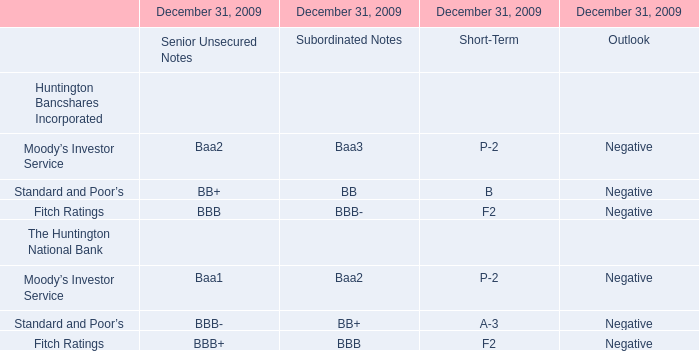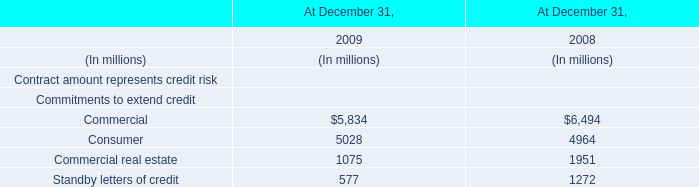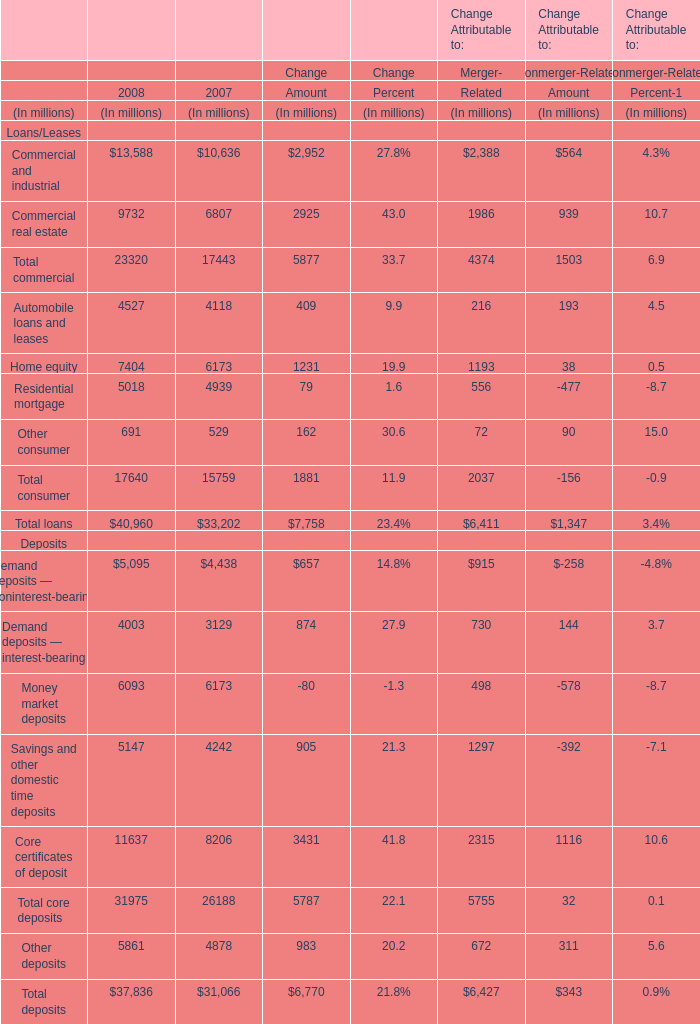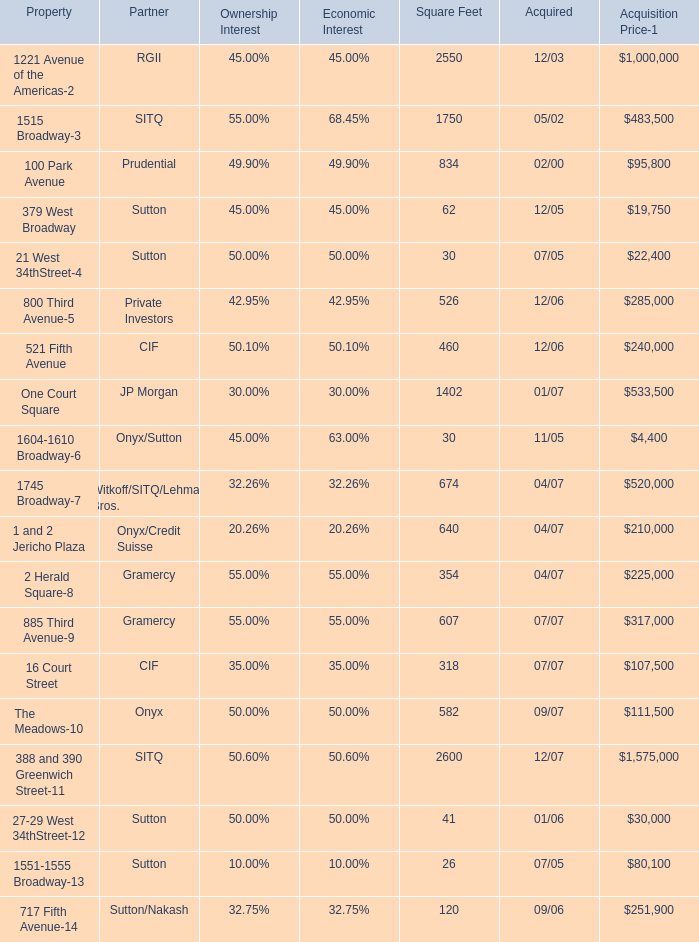In the year with largest amount of Commercial for Commitments to extend credit, what's the increasing rate of Commercial and industrial for Loans/Leases? 
Computations: ((13588 - 10636) / 10636)
Answer: 0.27755. 